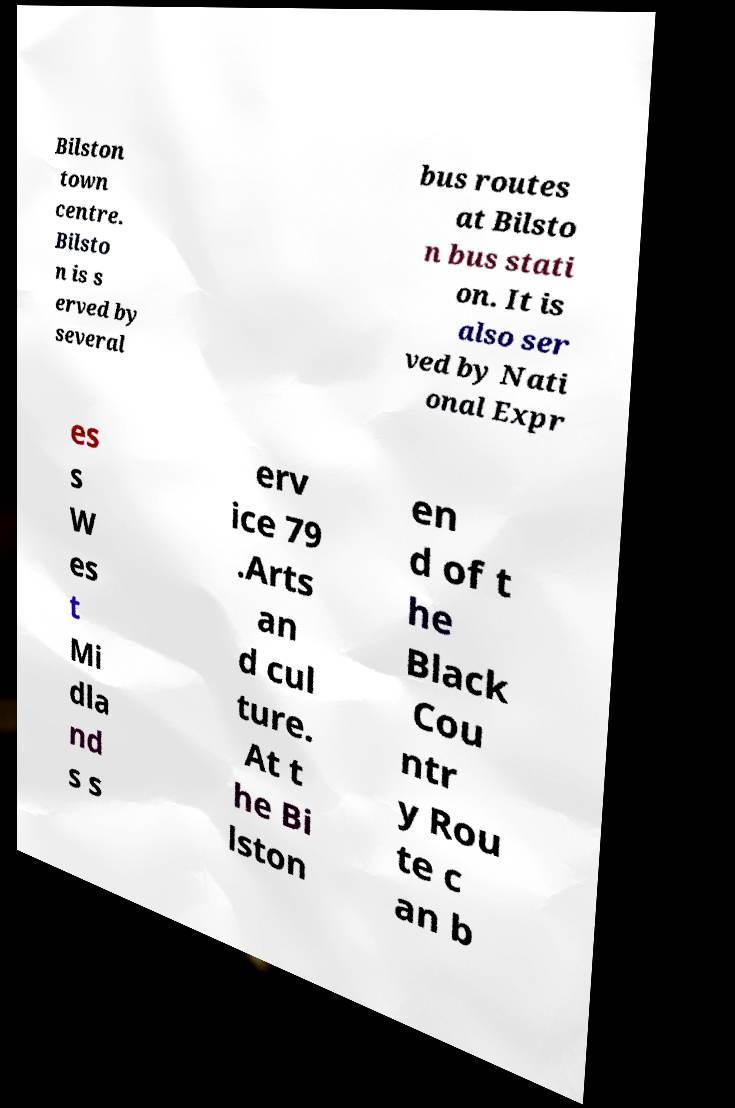Please identify and transcribe the text found in this image. Bilston town centre. Bilsto n is s erved by several bus routes at Bilsto n bus stati on. It is also ser ved by Nati onal Expr es s W es t Mi dla nd s s erv ice 79 .Arts an d cul ture. At t he Bi lston en d of t he Black Cou ntr y Rou te c an b 